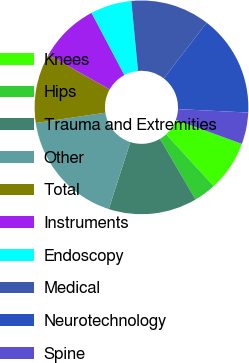<chart> <loc_0><loc_0><loc_500><loc_500><pie_chart><fcel>Knees<fcel>Hips<fcel>Trauma and Extremities<fcel>Other<fcel>Total<fcel>Instruments<fcel>Endoscopy<fcel>Medical<fcel>Neurotechnology<fcel>Spine<nl><fcel>7.65%<fcel>3.35%<fcel>13.4%<fcel>17.7%<fcel>10.52%<fcel>9.09%<fcel>6.22%<fcel>11.96%<fcel>15.33%<fcel>4.78%<nl></chart> 